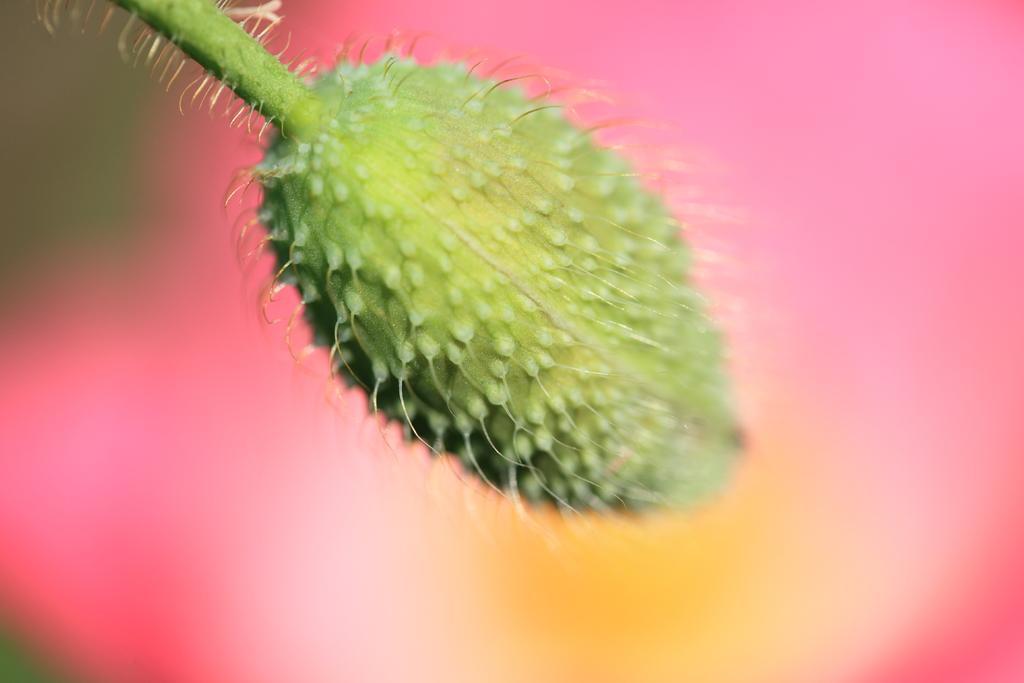How would you summarize this image in a sentence or two? In this image we can able to see a fruit which is of green in color. 